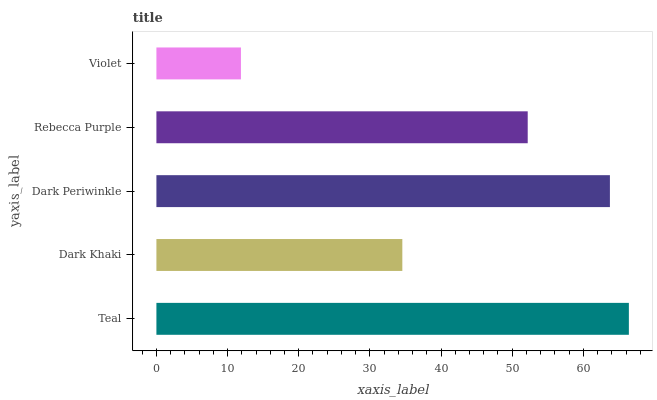Is Violet the minimum?
Answer yes or no. Yes. Is Teal the maximum?
Answer yes or no. Yes. Is Dark Khaki the minimum?
Answer yes or no. No. Is Dark Khaki the maximum?
Answer yes or no. No. Is Teal greater than Dark Khaki?
Answer yes or no. Yes. Is Dark Khaki less than Teal?
Answer yes or no. Yes. Is Dark Khaki greater than Teal?
Answer yes or no. No. Is Teal less than Dark Khaki?
Answer yes or no. No. Is Rebecca Purple the high median?
Answer yes or no. Yes. Is Rebecca Purple the low median?
Answer yes or no. Yes. Is Violet the high median?
Answer yes or no. No. Is Teal the low median?
Answer yes or no. No. 